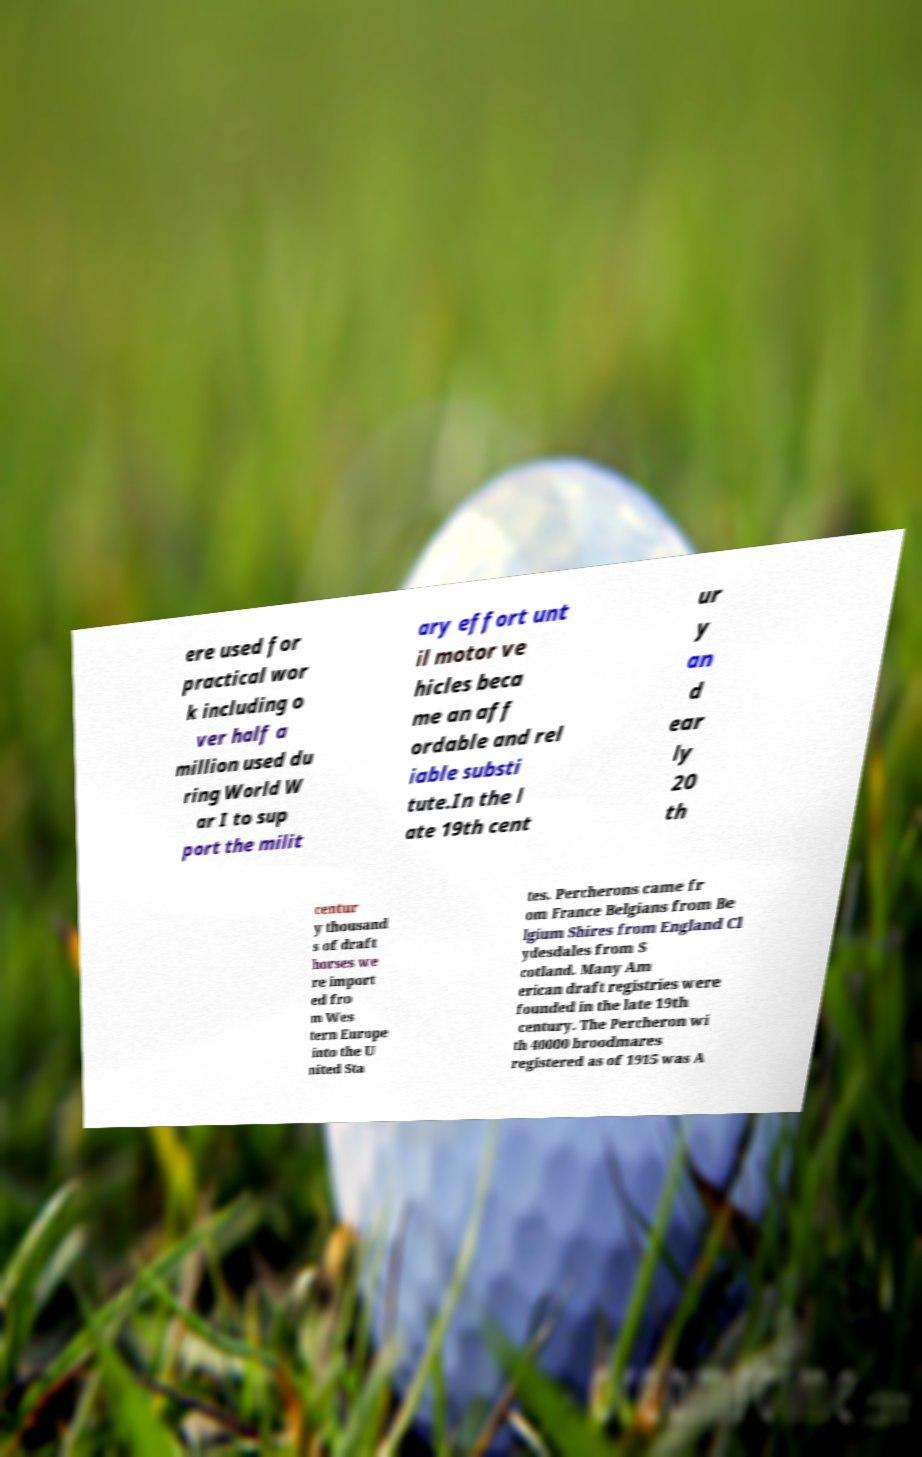Could you assist in decoding the text presented in this image and type it out clearly? ere used for practical wor k including o ver half a million used du ring World W ar I to sup port the milit ary effort unt il motor ve hicles beca me an aff ordable and rel iable substi tute.In the l ate 19th cent ur y an d ear ly 20 th centur y thousand s of draft horses we re import ed fro m Wes tern Europe into the U nited Sta tes. Percherons came fr om France Belgians from Be lgium Shires from England Cl ydesdales from S cotland. Many Am erican draft registries were founded in the late 19th century. The Percheron wi th 40000 broodmares registered as of 1915 was A 